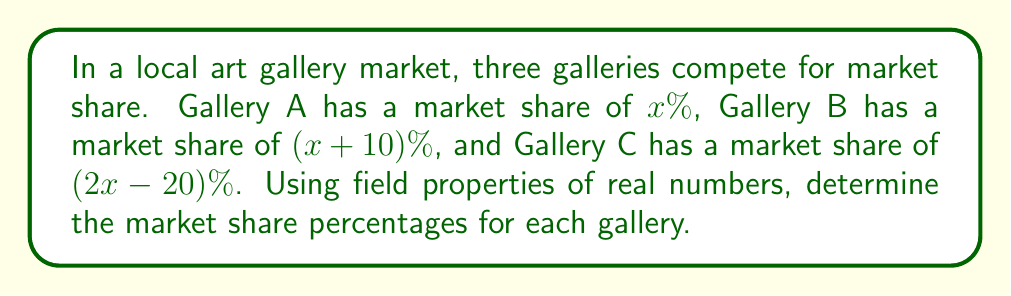Can you answer this question? Let's approach this step-by-step using field properties of real numbers:

1) First, we know that the total market share must equal 100%. We can express this as an equation:

   $x + (x+10) + (2x-20) = 100$

2) Simplify the left side of the equation using the field property of addition:

   $4x - 10 = 100$

3) Add 10 to both sides using the additive property of equality:

   $4x = 110$

4) Divide both sides by 4 using the multiplicative property of equality:

   $x = 27.5$

5) Now that we know $x$, we can calculate the market share for each gallery:

   Gallery A: $x = 27.5\%$
   Gallery B: $x + 10 = 27.5 + 10 = 37.5\%$
   Gallery C: $2x - 20 = 2(27.5) - 20 = 55 - 20 = 35\%$

6) Verify the result by adding all percentages:

   $27.5\% + 37.5\% + 35\% = 100\%$

The result aligns with the field property of closure under addition for real numbers.
Answer: Gallery A: 27.5%, Gallery B: 37.5%, Gallery C: 35% 